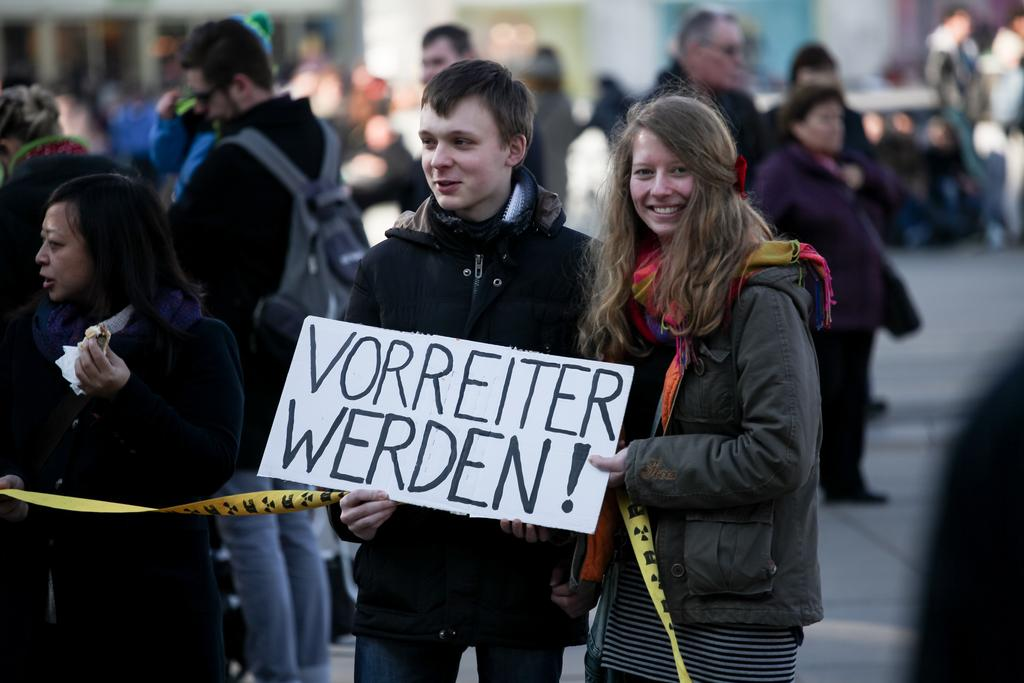Who are the main subjects in the image? There are two people in the center of the image. What are the two people holding? The two people are holding a placard. Can you describe the setting of the image? There are many people in the background of the image. Is there a stream of water flowing through the image? No, there is no stream of water visible in the image. 